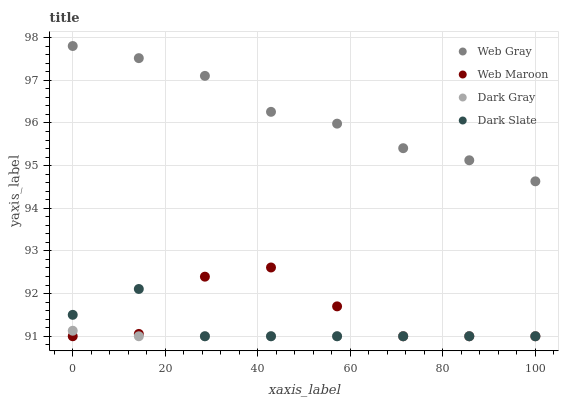Does Dark Gray have the minimum area under the curve?
Answer yes or no. Yes. Does Web Gray have the maximum area under the curve?
Answer yes or no. Yes. Does Dark Slate have the minimum area under the curve?
Answer yes or no. No. Does Dark Slate have the maximum area under the curve?
Answer yes or no. No. Is Dark Gray the smoothest?
Answer yes or no. Yes. Is Web Maroon the roughest?
Answer yes or no. Yes. Is Dark Slate the smoothest?
Answer yes or no. No. Is Dark Slate the roughest?
Answer yes or no. No. Does Dark Gray have the lowest value?
Answer yes or no. Yes. Does Web Gray have the lowest value?
Answer yes or no. No. Does Web Gray have the highest value?
Answer yes or no. Yes. Does Dark Slate have the highest value?
Answer yes or no. No. Is Dark Gray less than Web Gray?
Answer yes or no. Yes. Is Web Gray greater than Web Maroon?
Answer yes or no. Yes. Does Dark Slate intersect Web Maroon?
Answer yes or no. Yes. Is Dark Slate less than Web Maroon?
Answer yes or no. No. Is Dark Slate greater than Web Maroon?
Answer yes or no. No. Does Dark Gray intersect Web Gray?
Answer yes or no. No. 